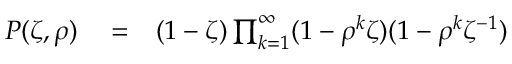<formula> <loc_0><loc_0><loc_500><loc_500>\begin{array} { r l r } { P ( \zeta , \rho ) } & = } & { ( 1 - \zeta ) \prod _ { k = 1 } ^ { \infty } ( 1 - \rho ^ { k } \zeta ) ( 1 - \rho ^ { k } \zeta ^ { - 1 } ) } \end{array}</formula> 